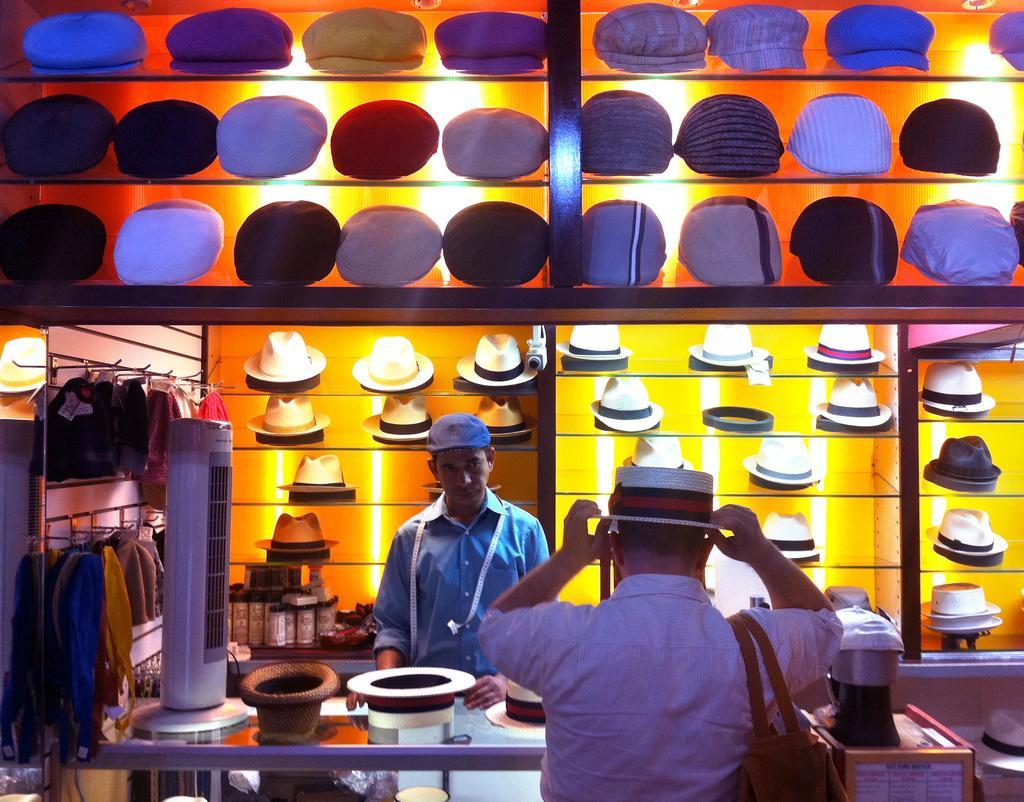Describe this image in one or two sentences. In this image I can see a cap store. In front the person is standing and wearing a bag and cap. Back I can see a person standing. I can see few caps in a rack. I can see a cap stand and cooler on the table. 